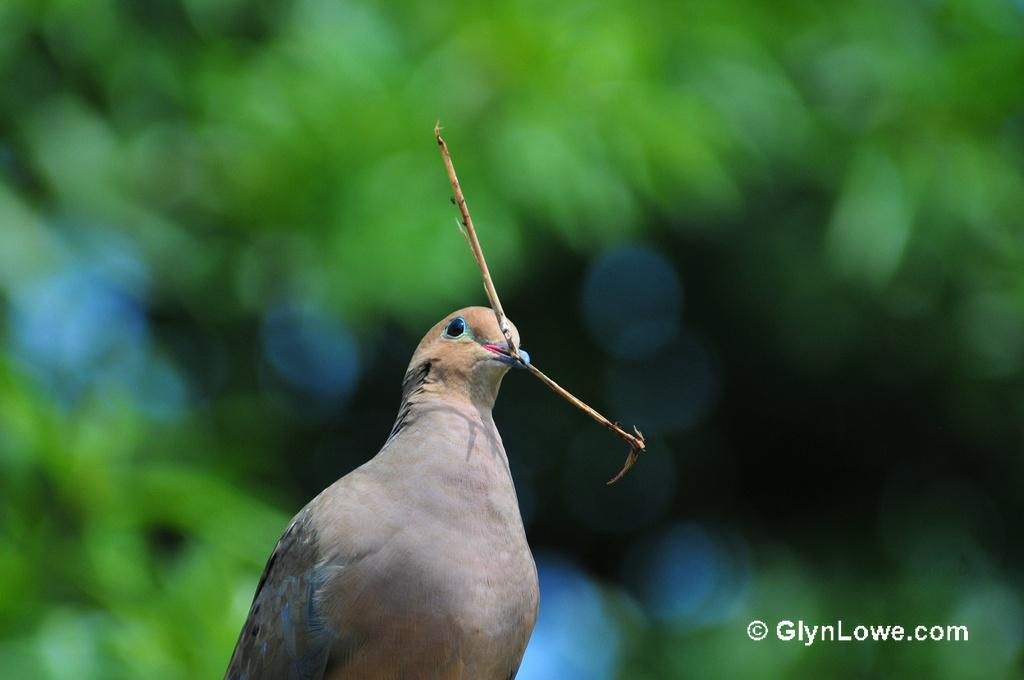What is the main subject in the front of the image? There is a bird in the front of the image. How would you describe the background of the image? The background of the image is blurry. Is there any text visible in the image? Yes, there is some text visible in the bottom right corner of the image. What type of quiver is the bird holding in the image? There is no quiver present in the image; the bird is not holding any object. 